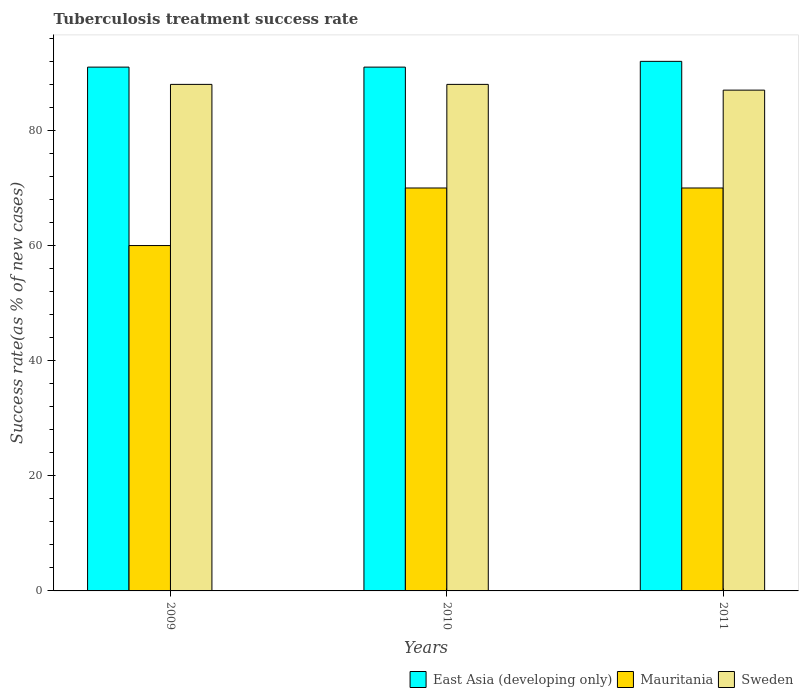How many different coloured bars are there?
Provide a succinct answer. 3. How many bars are there on the 2nd tick from the right?
Keep it short and to the point. 3. In which year was the tuberculosis treatment success rate in East Asia (developing only) maximum?
Offer a terse response. 2011. In which year was the tuberculosis treatment success rate in East Asia (developing only) minimum?
Provide a short and direct response. 2009. What is the total tuberculosis treatment success rate in Sweden in the graph?
Make the answer very short. 263. What is the difference between the tuberculosis treatment success rate in East Asia (developing only) in 2011 and the tuberculosis treatment success rate in Sweden in 2009?
Your response must be concise. 4. What is the average tuberculosis treatment success rate in Mauritania per year?
Make the answer very short. 66.67. In how many years, is the tuberculosis treatment success rate in East Asia (developing only) greater than 80 %?
Offer a very short reply. 3. What is the ratio of the tuberculosis treatment success rate in Mauritania in 2010 to that in 2011?
Your answer should be very brief. 1. Is the difference between the tuberculosis treatment success rate in Sweden in 2010 and 2011 greater than the difference between the tuberculosis treatment success rate in Mauritania in 2010 and 2011?
Make the answer very short. Yes. In how many years, is the tuberculosis treatment success rate in Sweden greater than the average tuberculosis treatment success rate in Sweden taken over all years?
Ensure brevity in your answer.  2. What does the 1st bar from the left in 2009 represents?
Ensure brevity in your answer.  East Asia (developing only). Is it the case that in every year, the sum of the tuberculosis treatment success rate in Mauritania and tuberculosis treatment success rate in East Asia (developing only) is greater than the tuberculosis treatment success rate in Sweden?
Give a very brief answer. Yes. Are all the bars in the graph horizontal?
Make the answer very short. No. Are the values on the major ticks of Y-axis written in scientific E-notation?
Give a very brief answer. No. Does the graph contain any zero values?
Offer a terse response. No. How many legend labels are there?
Provide a succinct answer. 3. What is the title of the graph?
Your response must be concise. Tuberculosis treatment success rate. What is the label or title of the X-axis?
Provide a short and direct response. Years. What is the label or title of the Y-axis?
Your answer should be compact. Success rate(as % of new cases). What is the Success rate(as % of new cases) in East Asia (developing only) in 2009?
Give a very brief answer. 91. What is the Success rate(as % of new cases) in Mauritania in 2009?
Offer a terse response. 60. What is the Success rate(as % of new cases) of Sweden in 2009?
Keep it short and to the point. 88. What is the Success rate(as % of new cases) of East Asia (developing only) in 2010?
Provide a short and direct response. 91. What is the Success rate(as % of new cases) in Mauritania in 2010?
Your response must be concise. 70. What is the Success rate(as % of new cases) in East Asia (developing only) in 2011?
Offer a very short reply. 92. Across all years, what is the maximum Success rate(as % of new cases) of East Asia (developing only)?
Your answer should be compact. 92. Across all years, what is the maximum Success rate(as % of new cases) of Mauritania?
Your response must be concise. 70. Across all years, what is the minimum Success rate(as % of new cases) in East Asia (developing only)?
Keep it short and to the point. 91. What is the total Success rate(as % of new cases) in East Asia (developing only) in the graph?
Provide a succinct answer. 274. What is the total Success rate(as % of new cases) of Mauritania in the graph?
Make the answer very short. 200. What is the total Success rate(as % of new cases) in Sweden in the graph?
Your answer should be very brief. 263. What is the difference between the Success rate(as % of new cases) in East Asia (developing only) in 2009 and that in 2010?
Ensure brevity in your answer.  0. What is the difference between the Success rate(as % of new cases) in Mauritania in 2009 and that in 2010?
Your response must be concise. -10. What is the difference between the Success rate(as % of new cases) of Sweden in 2009 and that in 2010?
Offer a terse response. 0. What is the difference between the Success rate(as % of new cases) of East Asia (developing only) in 2010 and that in 2011?
Give a very brief answer. -1. What is the difference between the Success rate(as % of new cases) of Sweden in 2010 and that in 2011?
Provide a succinct answer. 1. What is the difference between the Success rate(as % of new cases) in East Asia (developing only) in 2009 and the Success rate(as % of new cases) in Mauritania in 2011?
Give a very brief answer. 21. What is the difference between the Success rate(as % of new cases) in Mauritania in 2009 and the Success rate(as % of new cases) in Sweden in 2011?
Your answer should be compact. -27. What is the difference between the Success rate(as % of new cases) of East Asia (developing only) in 2010 and the Success rate(as % of new cases) of Mauritania in 2011?
Your answer should be very brief. 21. What is the average Success rate(as % of new cases) in East Asia (developing only) per year?
Your answer should be very brief. 91.33. What is the average Success rate(as % of new cases) of Mauritania per year?
Provide a short and direct response. 66.67. What is the average Success rate(as % of new cases) in Sweden per year?
Ensure brevity in your answer.  87.67. In the year 2009, what is the difference between the Success rate(as % of new cases) of East Asia (developing only) and Success rate(as % of new cases) of Mauritania?
Your answer should be very brief. 31. In the year 2009, what is the difference between the Success rate(as % of new cases) in East Asia (developing only) and Success rate(as % of new cases) in Sweden?
Give a very brief answer. 3. In the year 2009, what is the difference between the Success rate(as % of new cases) of Mauritania and Success rate(as % of new cases) of Sweden?
Provide a short and direct response. -28. In the year 2010, what is the difference between the Success rate(as % of new cases) of East Asia (developing only) and Success rate(as % of new cases) of Sweden?
Provide a short and direct response. 3. In the year 2011, what is the difference between the Success rate(as % of new cases) in Mauritania and Success rate(as % of new cases) in Sweden?
Offer a terse response. -17. What is the ratio of the Success rate(as % of new cases) of East Asia (developing only) in 2009 to that in 2010?
Offer a terse response. 1. What is the ratio of the Success rate(as % of new cases) in Sweden in 2009 to that in 2010?
Your answer should be compact. 1. What is the ratio of the Success rate(as % of new cases) in Mauritania in 2009 to that in 2011?
Your response must be concise. 0.86. What is the ratio of the Success rate(as % of new cases) of Sweden in 2009 to that in 2011?
Your response must be concise. 1.01. What is the ratio of the Success rate(as % of new cases) in Sweden in 2010 to that in 2011?
Your answer should be very brief. 1.01. What is the difference between the highest and the second highest Success rate(as % of new cases) in East Asia (developing only)?
Give a very brief answer. 1. What is the difference between the highest and the second highest Success rate(as % of new cases) of Mauritania?
Provide a short and direct response. 0. What is the difference between the highest and the second highest Success rate(as % of new cases) in Sweden?
Offer a very short reply. 0. What is the difference between the highest and the lowest Success rate(as % of new cases) in East Asia (developing only)?
Give a very brief answer. 1. What is the difference between the highest and the lowest Success rate(as % of new cases) of Mauritania?
Your answer should be very brief. 10. What is the difference between the highest and the lowest Success rate(as % of new cases) in Sweden?
Provide a short and direct response. 1. 